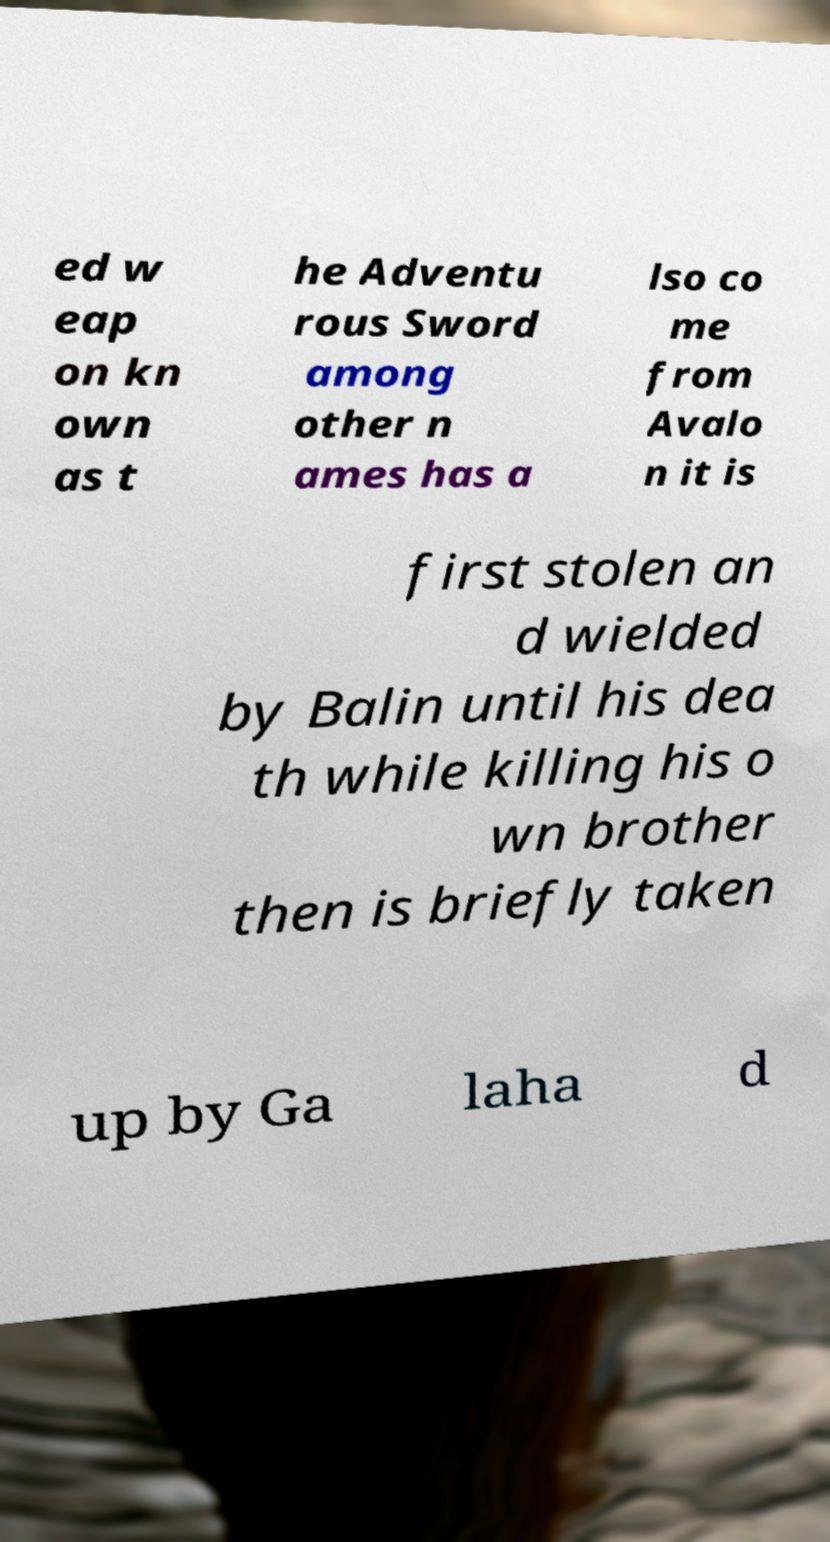What messages or text are displayed in this image? I need them in a readable, typed format. ed w eap on kn own as t he Adventu rous Sword among other n ames has a lso co me from Avalo n it is first stolen an d wielded by Balin until his dea th while killing his o wn brother then is briefly taken up by Ga laha d 